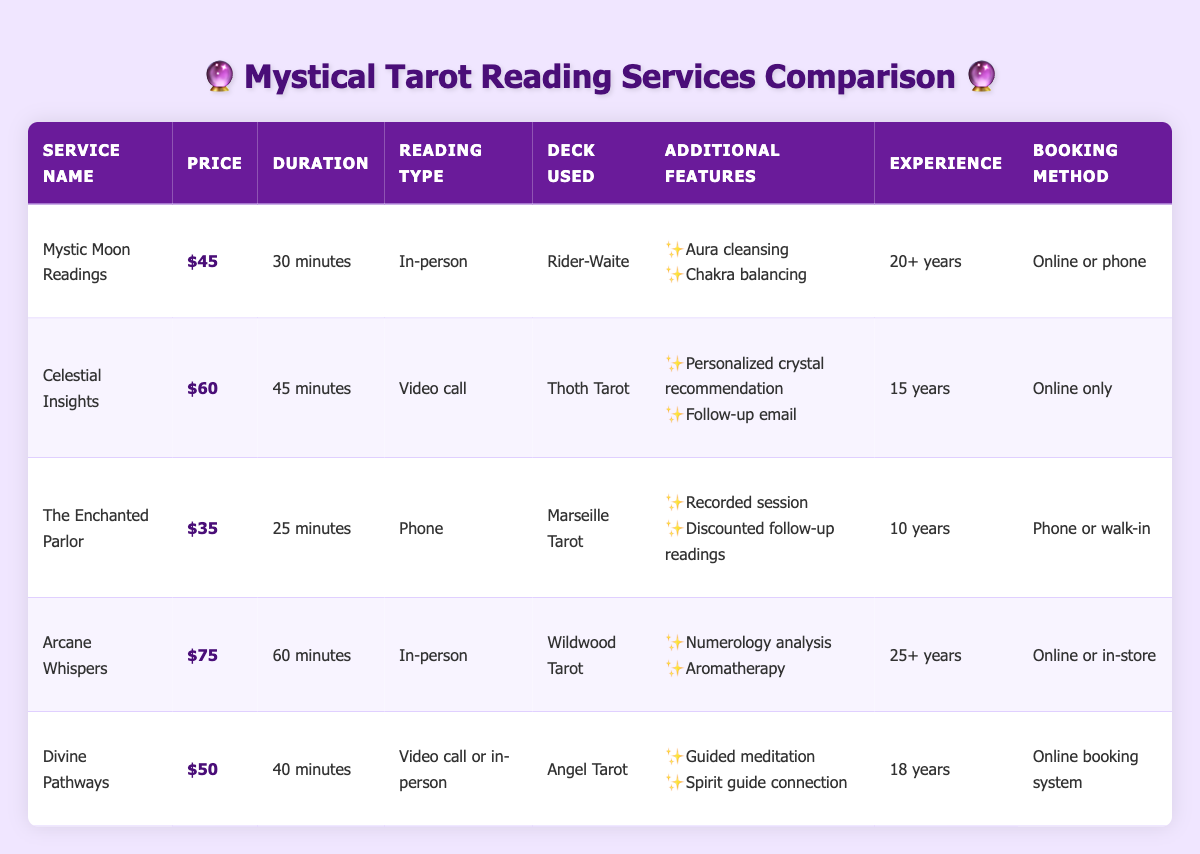What is the price for "The Enchanted Parlor" service? The price for "The Enchanted Parlor" is listed in the table under "Price," which shows $35.
Answer: $35 Which tarot reading service offers the longest session duration? By comparing the session durations in the table, "Arcane Whispers" has the longest duration at 60 minutes.
Answer: 60 minutes Is "Mystic Moon Readings" available for both online and phone bookings? The table indicates that "Mystic Moon Readings" can be booked online or by phone, confirming its availability on both platforms.
Answer: Yes What is the experience level of "Celestial Insights"? According to the table, "Celestial Insights" has an experience level of 15 years.
Answer: 15 years Which service has the highest price and what additional features does it offer? "Arcane Whispers" is priced at $75, and its additional features include numerology analysis and aromatherapy.
Answer: $75, numerology analysis, aromatherapy How much more does "Divine Pathways" cost compared to "The Enchanted Parlor"? The cost of "Divine Pathways" is $50 and "The Enchanted Parlor" is $35. The difference in price is $50 - $35 = $15.
Answer: $15 Are all the services offered in person? The table shows various reading types, including in-person, video calls, and phone readings, indicating that not all services are in-person.
Answer: No How many years of experience does the service with the second-highest price have? The service with the second-highest price is "Celestial Insights" at $60. According to the table, it has 15 years of experience.
Answer: 15 years 